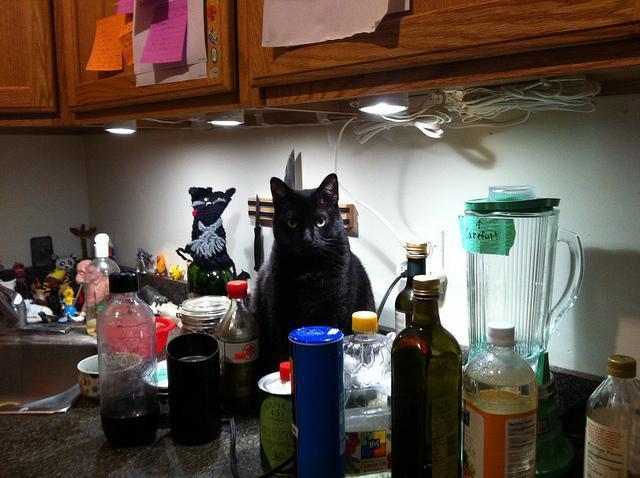How many animals are on the counter?
Give a very brief answer. 1. How many bottles are there?
Give a very brief answer. 7. How many giraffes are there?
Give a very brief answer. 0. 